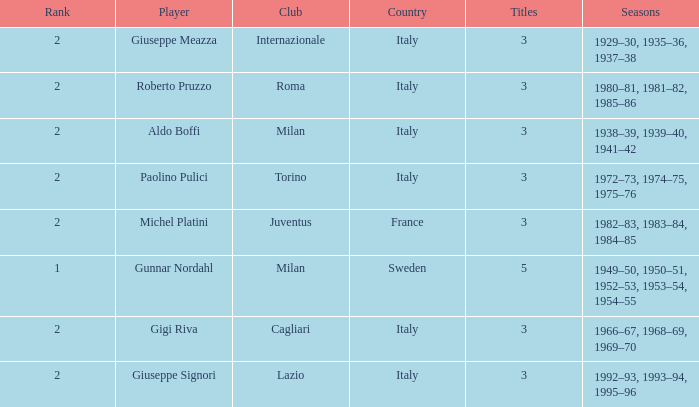How many rankings are associated with giuseppe meazza holding over 3 titles? 0.0. 